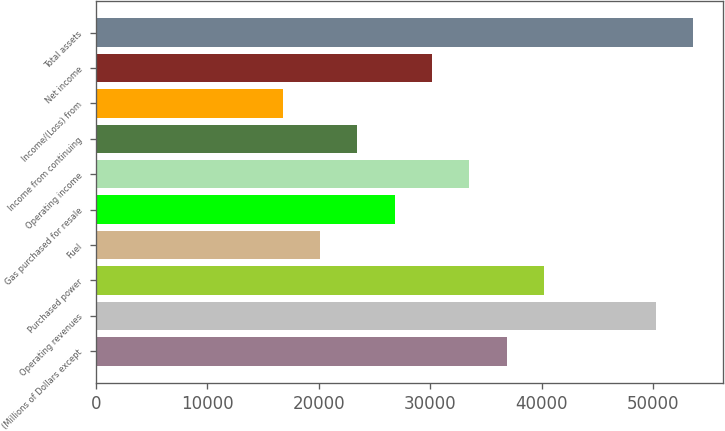Convert chart to OTSL. <chart><loc_0><loc_0><loc_500><loc_500><bar_chart><fcel>(Millions of Dollars except<fcel>Operating revenues<fcel>Purchased power<fcel>Fuel<fcel>Gas purchased for resale<fcel>Operating income<fcel>Income from continuing<fcel>Income/(Loss) from<fcel>Net income<fcel>Total assets<nl><fcel>36847.7<fcel>50246.5<fcel>40197.4<fcel>20099.2<fcel>26798.6<fcel>33498<fcel>23448.9<fcel>16749.5<fcel>30148.3<fcel>53596.2<nl></chart> 